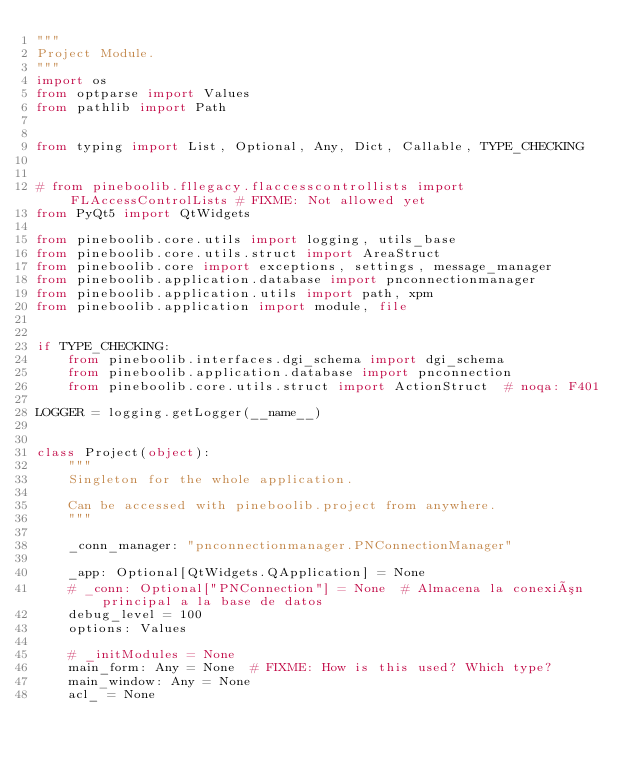Convert code to text. <code><loc_0><loc_0><loc_500><loc_500><_Python_>"""
Project Module.
"""
import os
from optparse import Values
from pathlib import Path


from typing import List, Optional, Any, Dict, Callable, TYPE_CHECKING


# from pineboolib.fllegacy.flaccesscontrollists import FLAccessControlLists # FIXME: Not allowed yet
from PyQt5 import QtWidgets

from pineboolib.core.utils import logging, utils_base
from pineboolib.core.utils.struct import AreaStruct
from pineboolib.core import exceptions, settings, message_manager
from pineboolib.application.database import pnconnectionmanager
from pineboolib.application.utils import path, xpm
from pineboolib.application import module, file


if TYPE_CHECKING:
    from pineboolib.interfaces.dgi_schema import dgi_schema
    from pineboolib.application.database import pnconnection
    from pineboolib.core.utils.struct import ActionStruct  # noqa: F401

LOGGER = logging.getLogger(__name__)


class Project(object):
    """
    Singleton for the whole application.

    Can be accessed with pineboolib.project from anywhere.
    """

    _conn_manager: "pnconnectionmanager.PNConnectionManager"

    _app: Optional[QtWidgets.QApplication] = None
    # _conn: Optional["PNConnection"] = None  # Almacena la conexión principal a la base de datos
    debug_level = 100
    options: Values

    # _initModules = None
    main_form: Any = None  # FIXME: How is this used? Which type?
    main_window: Any = None
    acl_ = None</code> 